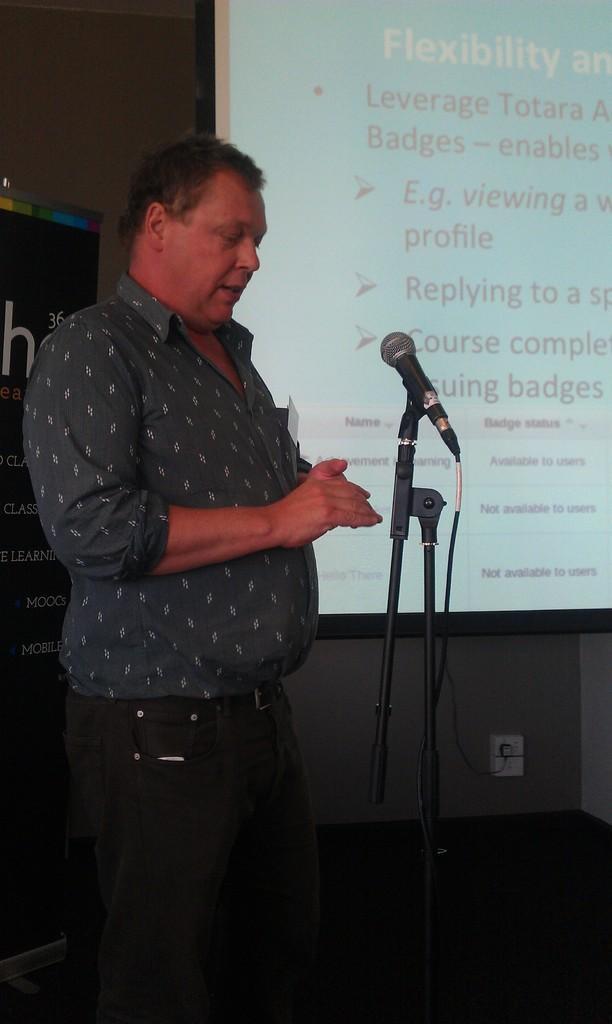Please provide a concise description of this image. In the picture we can see a man standing and talking something near the microphone which is in the stand and beside him we can see a screen with some information on it and behind the screen we can see a wall with a black color board on it with some information. 